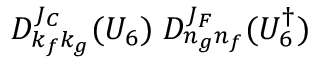Convert formula to latex. <formula><loc_0><loc_0><loc_500><loc_500>D _ { k _ { f } k _ { g } } ^ { J _ { C } } ( U _ { 6 } ) \, D _ { n _ { g } n _ { f } } ^ { J _ { F } } ( U _ { 6 } ^ { \dagger } )</formula> 